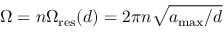Convert formula to latex. <formula><loc_0><loc_0><loc_500><loc_500>\Omega = n \Omega _ { r e s } ( d ) = 2 \pi n \sqrt { a _ { \max } / d }</formula> 